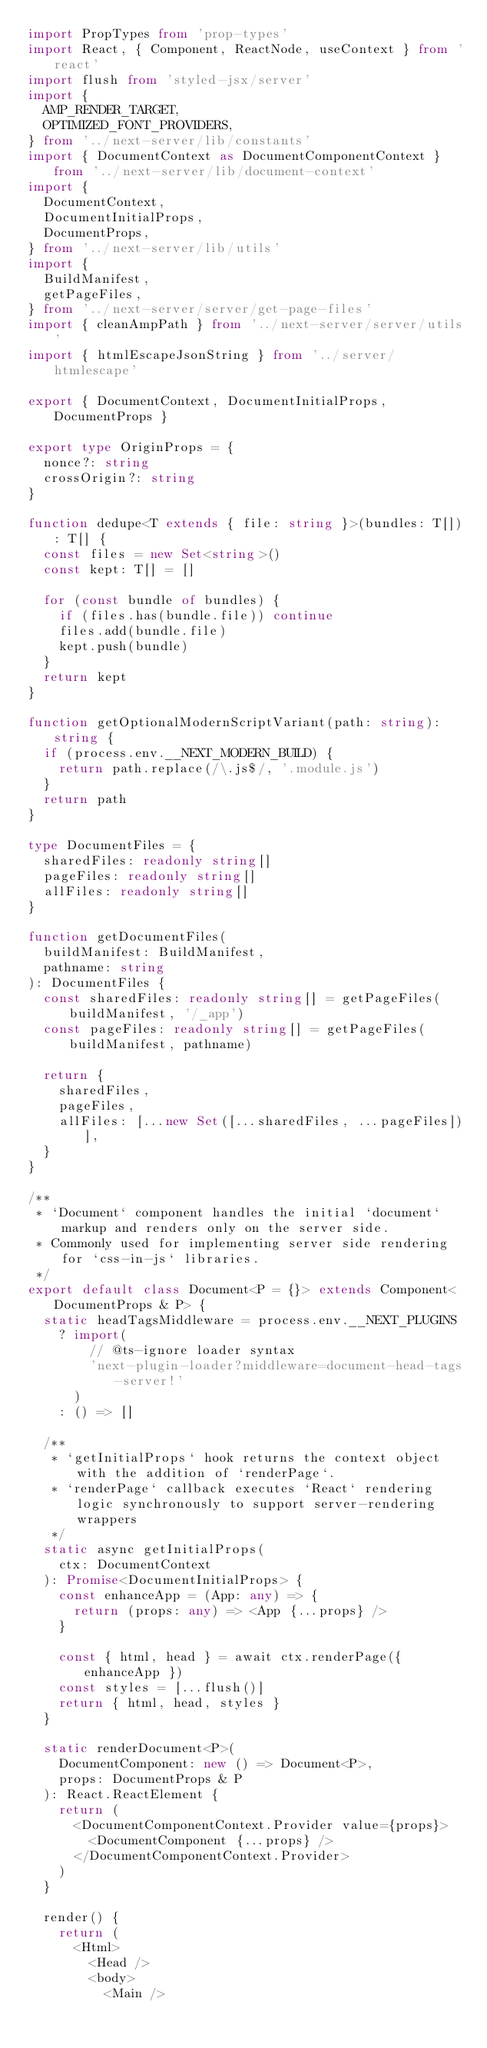<code> <loc_0><loc_0><loc_500><loc_500><_TypeScript_>import PropTypes from 'prop-types'
import React, { Component, ReactNode, useContext } from 'react'
import flush from 'styled-jsx/server'
import {
  AMP_RENDER_TARGET,
  OPTIMIZED_FONT_PROVIDERS,
} from '../next-server/lib/constants'
import { DocumentContext as DocumentComponentContext } from '../next-server/lib/document-context'
import {
  DocumentContext,
  DocumentInitialProps,
  DocumentProps,
} from '../next-server/lib/utils'
import {
  BuildManifest,
  getPageFiles,
} from '../next-server/server/get-page-files'
import { cleanAmpPath } from '../next-server/server/utils'
import { htmlEscapeJsonString } from '../server/htmlescape'

export { DocumentContext, DocumentInitialProps, DocumentProps }

export type OriginProps = {
  nonce?: string
  crossOrigin?: string
}

function dedupe<T extends { file: string }>(bundles: T[]): T[] {
  const files = new Set<string>()
  const kept: T[] = []

  for (const bundle of bundles) {
    if (files.has(bundle.file)) continue
    files.add(bundle.file)
    kept.push(bundle)
  }
  return kept
}

function getOptionalModernScriptVariant(path: string): string {
  if (process.env.__NEXT_MODERN_BUILD) {
    return path.replace(/\.js$/, '.module.js')
  }
  return path
}

type DocumentFiles = {
  sharedFiles: readonly string[]
  pageFiles: readonly string[]
  allFiles: readonly string[]
}

function getDocumentFiles(
  buildManifest: BuildManifest,
  pathname: string
): DocumentFiles {
  const sharedFiles: readonly string[] = getPageFiles(buildManifest, '/_app')
  const pageFiles: readonly string[] = getPageFiles(buildManifest, pathname)

  return {
    sharedFiles,
    pageFiles,
    allFiles: [...new Set([...sharedFiles, ...pageFiles])],
  }
}

/**
 * `Document` component handles the initial `document` markup and renders only on the server side.
 * Commonly used for implementing server side rendering for `css-in-js` libraries.
 */
export default class Document<P = {}> extends Component<DocumentProps & P> {
  static headTagsMiddleware = process.env.__NEXT_PLUGINS
    ? import(
        // @ts-ignore loader syntax
        'next-plugin-loader?middleware=document-head-tags-server!'
      )
    : () => []

  /**
   * `getInitialProps` hook returns the context object with the addition of `renderPage`.
   * `renderPage` callback executes `React` rendering logic synchronously to support server-rendering wrappers
   */
  static async getInitialProps(
    ctx: DocumentContext
  ): Promise<DocumentInitialProps> {
    const enhanceApp = (App: any) => {
      return (props: any) => <App {...props} />
    }

    const { html, head } = await ctx.renderPage({ enhanceApp })
    const styles = [...flush()]
    return { html, head, styles }
  }

  static renderDocument<P>(
    DocumentComponent: new () => Document<P>,
    props: DocumentProps & P
  ): React.ReactElement {
    return (
      <DocumentComponentContext.Provider value={props}>
        <DocumentComponent {...props} />
      </DocumentComponentContext.Provider>
    )
  }

  render() {
    return (
      <Html>
        <Head />
        <body>
          <Main /></code> 